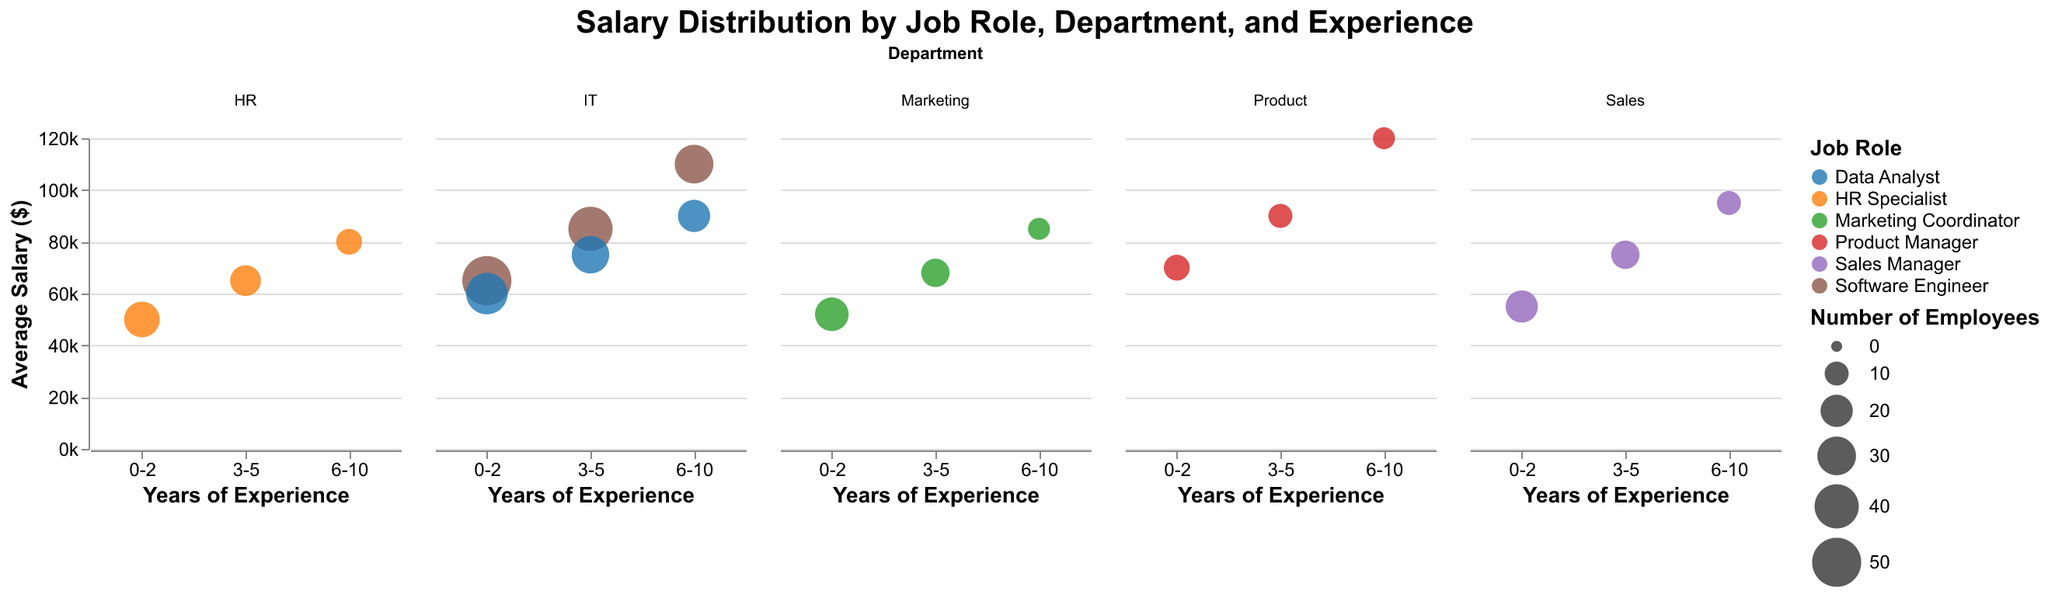Basic questions:
1. What does the title of the figure say? The title is displayed at the top of the figure and clearly states the main topic of the visual representation. It reads: "Salary Distribution by Job Role, Department, and Experience." This indicates the figure shows the distribution of salaries across various job roles, departments, and years of experience.
Answer: Salary Distribution by Job Role, Department, and Experience 2. What does the x-axis represent? The x-axis represents "Years of Experience," as seen from the labels 0-2, 3-5, and 6-10 beneath the axis. This x-axis shows the different experience brackets for employees depicted in the figure.
Answer: Years of Experience 3. What does the y-axis represent? The y-axis indicates "Average Salary ($)," which is apparent from the label on the left side of the figure. This axis measures the average salaries of employees within the categories presented.
Answer: Average Salary ($) 4. What does the size of each bubble represent? The size of each bubble encodes the "Number of Employees." Bigger bubbles indicate a higher number of employees for that particular job role and experience level within a department.
Answer: Number of Employees 5. What does the color of each bubble represent? The color of each bubble distinguishes between different "Job Roles." Each job role is assigned a different color to differentiate the bubbles visually.
Answer: Job Roles Compositional questions:
6. What is the average salary for Data Analysts with 0-2 and 3-5 years of experience combined? To find the combined average salary, first sum up the salaries for Data Analysts with 0-2 years of experience ($60,000) and 3-5 years of experience ($75,000). Then, divide by 2 to get the average. This calculation gives: (60,000 + 75,000) / 2.
Answer: $67,500 Comparison questions:
7. Which job role in IT department has the highest average salary for 6-10 years of experience? Compare the average salaries within the IT department for job roles shown in the 6-10 years of experience bracket. The roles are Software Engineer ($110,000) and Data Analyst ($90,000). Software Engineer has the higher average salary.
Answer: Software Engineer 8. Among all job roles with 0-2 years of experience, which department has the highest average salary? Compare the bubbles representing 0-2 years of experience across all departments. The highest average salary is shown by the Product Manager in the Product department with $70,000.
Answer: Product Chart-Type Specific questions:
9. Which department has the most diverse average salary distribution across years of experience? We determine diversity by looking at the departments with the widest range of average salaries over different experience levels. The IT department shows the most diverse range, from $60,000 (Data Analysts with 0-2 years) to $110,000 (Software Engineers with 6-10 years).
Answer: IT 10. For which job role do you see the largest bubble for 0-2 years of experience? The bubbles encode the number of employees, so we identify the largest bubble (size) for 0-2 years of experience. The largest bubble belongs to the Software Engineer in the IT department, indicating 50 employees.
Answer: Software Engineer 